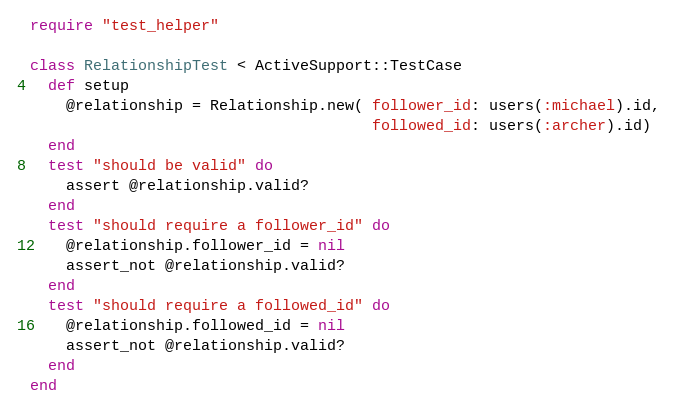<code> <loc_0><loc_0><loc_500><loc_500><_Ruby_>require "test_helper"

class RelationshipTest < ActiveSupport::TestCase
  def setup
    @relationship = Relationship.new( follower_id: users(:michael).id,
                                      followed_id: users(:archer).id)
  end
  test "should be valid" do
    assert @relationship.valid?
  end
  test "should require a follower_id" do
    @relationship.follower_id = nil
    assert_not @relationship.valid?
  end
  test "should require a followed_id" do
    @relationship.followed_id = nil
    assert_not @relationship.valid?
  end
end
</code> 